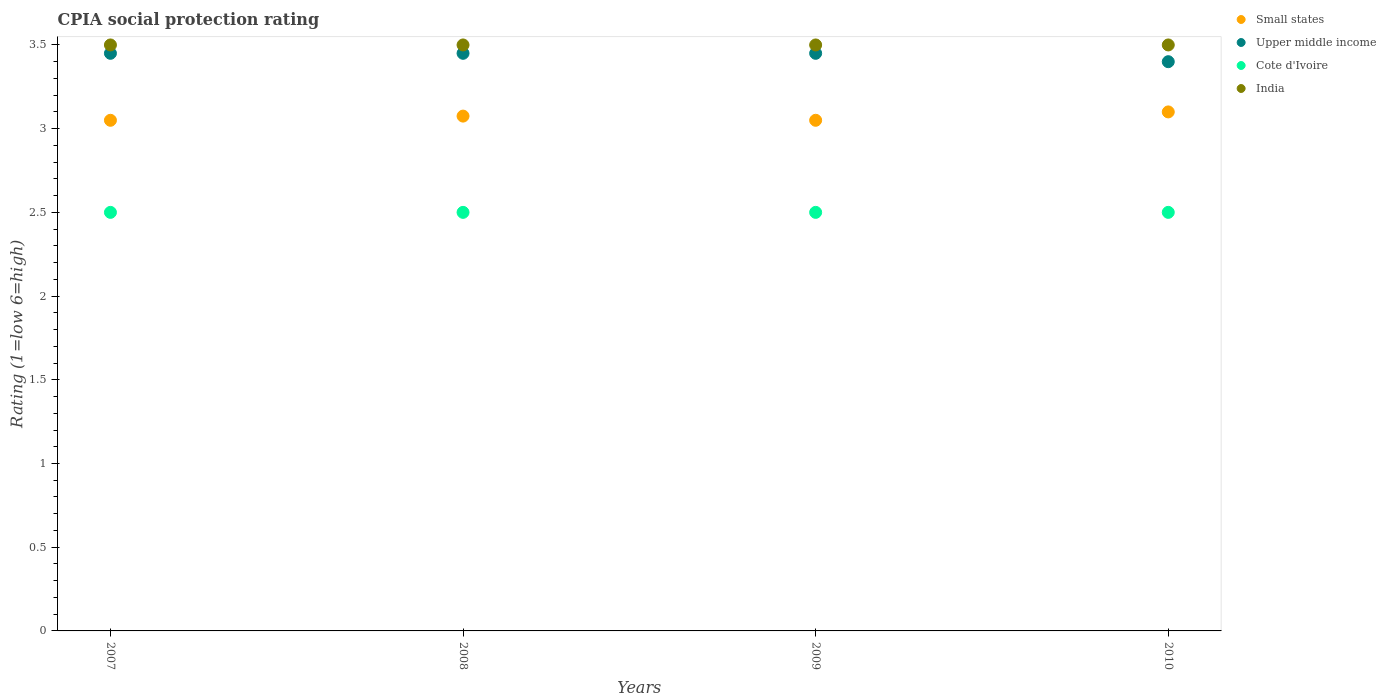How many different coloured dotlines are there?
Keep it short and to the point. 4. Is the number of dotlines equal to the number of legend labels?
Make the answer very short. Yes. What is the CPIA rating in Small states in 2007?
Keep it short and to the point. 3.05. In which year was the CPIA rating in Upper middle income minimum?
Offer a very short reply. 2010. What is the difference between the CPIA rating in Upper middle income in 2007 and that in 2010?
Offer a very short reply. 0.05. What is the difference between the CPIA rating in Small states in 2010 and the CPIA rating in Upper middle income in 2009?
Ensure brevity in your answer.  -0.35. What is the average CPIA rating in Cote d'Ivoire per year?
Provide a short and direct response. 2.5. In the year 2009, what is the difference between the CPIA rating in Upper middle income and CPIA rating in Small states?
Your response must be concise. 0.4. In how many years, is the CPIA rating in Small states greater than 2.2?
Provide a short and direct response. 4. What is the ratio of the CPIA rating in Small states in 2008 to that in 2009?
Ensure brevity in your answer.  1.01. Is the CPIA rating in Cote d'Ivoire in 2007 less than that in 2009?
Give a very brief answer. No. What is the difference between the highest and the second highest CPIA rating in Small states?
Your answer should be very brief. 0.02. Is it the case that in every year, the sum of the CPIA rating in Cote d'Ivoire and CPIA rating in Small states  is greater than the sum of CPIA rating in Upper middle income and CPIA rating in India?
Ensure brevity in your answer.  No. Does the CPIA rating in India monotonically increase over the years?
Offer a terse response. No. Is the CPIA rating in Upper middle income strictly less than the CPIA rating in India over the years?
Offer a terse response. Yes. What is the difference between two consecutive major ticks on the Y-axis?
Your answer should be very brief. 0.5. Does the graph contain any zero values?
Ensure brevity in your answer.  No. Does the graph contain grids?
Offer a very short reply. No. How are the legend labels stacked?
Provide a succinct answer. Vertical. What is the title of the graph?
Your answer should be very brief. CPIA social protection rating. What is the label or title of the Y-axis?
Give a very brief answer. Rating (1=low 6=high). What is the Rating (1=low 6=high) of Small states in 2007?
Your answer should be very brief. 3.05. What is the Rating (1=low 6=high) of Upper middle income in 2007?
Keep it short and to the point. 3.45. What is the Rating (1=low 6=high) in Cote d'Ivoire in 2007?
Offer a very short reply. 2.5. What is the Rating (1=low 6=high) in Small states in 2008?
Make the answer very short. 3.08. What is the Rating (1=low 6=high) in Upper middle income in 2008?
Offer a terse response. 3.45. What is the Rating (1=low 6=high) of Cote d'Ivoire in 2008?
Provide a short and direct response. 2.5. What is the Rating (1=low 6=high) of Small states in 2009?
Offer a terse response. 3.05. What is the Rating (1=low 6=high) of Upper middle income in 2009?
Keep it short and to the point. 3.45. What is the Rating (1=low 6=high) in India in 2009?
Your response must be concise. 3.5. What is the Rating (1=low 6=high) of Small states in 2010?
Keep it short and to the point. 3.1. What is the Rating (1=low 6=high) of India in 2010?
Offer a terse response. 3.5. Across all years, what is the maximum Rating (1=low 6=high) in Upper middle income?
Your answer should be very brief. 3.45. Across all years, what is the maximum Rating (1=low 6=high) of India?
Your answer should be compact. 3.5. Across all years, what is the minimum Rating (1=low 6=high) in Small states?
Your response must be concise. 3.05. Across all years, what is the minimum Rating (1=low 6=high) in Upper middle income?
Make the answer very short. 3.4. Across all years, what is the minimum Rating (1=low 6=high) in Cote d'Ivoire?
Provide a short and direct response. 2.5. What is the total Rating (1=low 6=high) of Small states in the graph?
Your response must be concise. 12.28. What is the total Rating (1=low 6=high) of Upper middle income in the graph?
Your answer should be very brief. 13.75. What is the difference between the Rating (1=low 6=high) of Small states in 2007 and that in 2008?
Your response must be concise. -0.03. What is the difference between the Rating (1=low 6=high) in India in 2007 and that in 2008?
Keep it short and to the point. 0. What is the difference between the Rating (1=low 6=high) of Cote d'Ivoire in 2007 and that in 2010?
Your answer should be very brief. 0. What is the difference between the Rating (1=low 6=high) of Small states in 2008 and that in 2009?
Your answer should be compact. 0.03. What is the difference between the Rating (1=low 6=high) of Upper middle income in 2008 and that in 2009?
Your response must be concise. 0. What is the difference between the Rating (1=low 6=high) of Cote d'Ivoire in 2008 and that in 2009?
Your response must be concise. 0. What is the difference between the Rating (1=low 6=high) in India in 2008 and that in 2009?
Make the answer very short. 0. What is the difference between the Rating (1=low 6=high) of Small states in 2008 and that in 2010?
Your answer should be very brief. -0.03. What is the difference between the Rating (1=low 6=high) in Small states in 2009 and that in 2010?
Provide a succinct answer. -0.05. What is the difference between the Rating (1=low 6=high) of Upper middle income in 2009 and that in 2010?
Provide a short and direct response. 0.05. What is the difference between the Rating (1=low 6=high) in Cote d'Ivoire in 2009 and that in 2010?
Ensure brevity in your answer.  0. What is the difference between the Rating (1=low 6=high) in India in 2009 and that in 2010?
Provide a short and direct response. 0. What is the difference between the Rating (1=low 6=high) of Small states in 2007 and the Rating (1=low 6=high) of Upper middle income in 2008?
Offer a very short reply. -0.4. What is the difference between the Rating (1=low 6=high) in Small states in 2007 and the Rating (1=low 6=high) in Cote d'Ivoire in 2008?
Keep it short and to the point. 0.55. What is the difference between the Rating (1=low 6=high) in Small states in 2007 and the Rating (1=low 6=high) in India in 2008?
Offer a terse response. -0.45. What is the difference between the Rating (1=low 6=high) of Cote d'Ivoire in 2007 and the Rating (1=low 6=high) of India in 2008?
Your answer should be very brief. -1. What is the difference between the Rating (1=low 6=high) in Small states in 2007 and the Rating (1=low 6=high) in Cote d'Ivoire in 2009?
Your response must be concise. 0.55. What is the difference between the Rating (1=low 6=high) in Small states in 2007 and the Rating (1=low 6=high) in India in 2009?
Your response must be concise. -0.45. What is the difference between the Rating (1=low 6=high) in Upper middle income in 2007 and the Rating (1=low 6=high) in Cote d'Ivoire in 2009?
Your answer should be very brief. 0.95. What is the difference between the Rating (1=low 6=high) of Cote d'Ivoire in 2007 and the Rating (1=low 6=high) of India in 2009?
Your answer should be very brief. -1. What is the difference between the Rating (1=low 6=high) of Small states in 2007 and the Rating (1=low 6=high) of Upper middle income in 2010?
Offer a terse response. -0.35. What is the difference between the Rating (1=low 6=high) of Small states in 2007 and the Rating (1=low 6=high) of Cote d'Ivoire in 2010?
Keep it short and to the point. 0.55. What is the difference between the Rating (1=low 6=high) of Small states in 2007 and the Rating (1=low 6=high) of India in 2010?
Keep it short and to the point. -0.45. What is the difference between the Rating (1=low 6=high) of Cote d'Ivoire in 2007 and the Rating (1=low 6=high) of India in 2010?
Your response must be concise. -1. What is the difference between the Rating (1=low 6=high) in Small states in 2008 and the Rating (1=low 6=high) in Upper middle income in 2009?
Keep it short and to the point. -0.38. What is the difference between the Rating (1=low 6=high) in Small states in 2008 and the Rating (1=low 6=high) in Cote d'Ivoire in 2009?
Provide a short and direct response. 0.57. What is the difference between the Rating (1=low 6=high) in Small states in 2008 and the Rating (1=low 6=high) in India in 2009?
Your answer should be compact. -0.42. What is the difference between the Rating (1=low 6=high) of Upper middle income in 2008 and the Rating (1=low 6=high) of India in 2009?
Provide a short and direct response. -0.05. What is the difference between the Rating (1=low 6=high) in Cote d'Ivoire in 2008 and the Rating (1=low 6=high) in India in 2009?
Your answer should be very brief. -1. What is the difference between the Rating (1=low 6=high) in Small states in 2008 and the Rating (1=low 6=high) in Upper middle income in 2010?
Your answer should be very brief. -0.33. What is the difference between the Rating (1=low 6=high) in Small states in 2008 and the Rating (1=low 6=high) in Cote d'Ivoire in 2010?
Your answer should be very brief. 0.57. What is the difference between the Rating (1=low 6=high) in Small states in 2008 and the Rating (1=low 6=high) in India in 2010?
Keep it short and to the point. -0.42. What is the difference between the Rating (1=low 6=high) of Small states in 2009 and the Rating (1=low 6=high) of Upper middle income in 2010?
Your response must be concise. -0.35. What is the difference between the Rating (1=low 6=high) in Small states in 2009 and the Rating (1=low 6=high) in Cote d'Ivoire in 2010?
Make the answer very short. 0.55. What is the difference between the Rating (1=low 6=high) in Small states in 2009 and the Rating (1=low 6=high) in India in 2010?
Keep it short and to the point. -0.45. What is the average Rating (1=low 6=high) in Small states per year?
Provide a short and direct response. 3.07. What is the average Rating (1=low 6=high) of Upper middle income per year?
Offer a terse response. 3.44. In the year 2007, what is the difference between the Rating (1=low 6=high) of Small states and Rating (1=low 6=high) of Cote d'Ivoire?
Give a very brief answer. 0.55. In the year 2007, what is the difference between the Rating (1=low 6=high) of Small states and Rating (1=low 6=high) of India?
Give a very brief answer. -0.45. In the year 2007, what is the difference between the Rating (1=low 6=high) in Upper middle income and Rating (1=low 6=high) in India?
Provide a short and direct response. -0.05. In the year 2008, what is the difference between the Rating (1=low 6=high) of Small states and Rating (1=low 6=high) of Upper middle income?
Keep it short and to the point. -0.38. In the year 2008, what is the difference between the Rating (1=low 6=high) in Small states and Rating (1=low 6=high) in Cote d'Ivoire?
Your answer should be compact. 0.57. In the year 2008, what is the difference between the Rating (1=low 6=high) in Small states and Rating (1=low 6=high) in India?
Ensure brevity in your answer.  -0.42. In the year 2009, what is the difference between the Rating (1=low 6=high) of Small states and Rating (1=low 6=high) of Cote d'Ivoire?
Offer a terse response. 0.55. In the year 2009, what is the difference between the Rating (1=low 6=high) of Small states and Rating (1=low 6=high) of India?
Provide a short and direct response. -0.45. In the year 2009, what is the difference between the Rating (1=low 6=high) of Upper middle income and Rating (1=low 6=high) of Cote d'Ivoire?
Offer a terse response. 0.95. In the year 2009, what is the difference between the Rating (1=low 6=high) in Cote d'Ivoire and Rating (1=low 6=high) in India?
Keep it short and to the point. -1. In the year 2010, what is the difference between the Rating (1=low 6=high) of Small states and Rating (1=low 6=high) of Cote d'Ivoire?
Give a very brief answer. 0.6. In the year 2010, what is the difference between the Rating (1=low 6=high) of Upper middle income and Rating (1=low 6=high) of India?
Make the answer very short. -0.1. What is the ratio of the Rating (1=low 6=high) of Cote d'Ivoire in 2007 to that in 2008?
Provide a succinct answer. 1. What is the ratio of the Rating (1=low 6=high) of India in 2007 to that in 2008?
Your answer should be compact. 1. What is the ratio of the Rating (1=low 6=high) of Small states in 2007 to that in 2009?
Make the answer very short. 1. What is the ratio of the Rating (1=low 6=high) of Cote d'Ivoire in 2007 to that in 2009?
Provide a succinct answer. 1. What is the ratio of the Rating (1=low 6=high) in India in 2007 to that in 2009?
Make the answer very short. 1. What is the ratio of the Rating (1=low 6=high) of Small states in 2007 to that in 2010?
Offer a terse response. 0.98. What is the ratio of the Rating (1=low 6=high) in Upper middle income in 2007 to that in 2010?
Offer a very short reply. 1.01. What is the ratio of the Rating (1=low 6=high) of Cote d'Ivoire in 2007 to that in 2010?
Provide a short and direct response. 1. What is the ratio of the Rating (1=low 6=high) of India in 2007 to that in 2010?
Make the answer very short. 1. What is the ratio of the Rating (1=low 6=high) in Small states in 2008 to that in 2009?
Make the answer very short. 1.01. What is the ratio of the Rating (1=low 6=high) in Upper middle income in 2008 to that in 2009?
Keep it short and to the point. 1. What is the ratio of the Rating (1=low 6=high) of India in 2008 to that in 2009?
Your answer should be very brief. 1. What is the ratio of the Rating (1=low 6=high) in Upper middle income in 2008 to that in 2010?
Offer a terse response. 1.01. What is the ratio of the Rating (1=low 6=high) in India in 2008 to that in 2010?
Offer a very short reply. 1. What is the ratio of the Rating (1=low 6=high) of Small states in 2009 to that in 2010?
Give a very brief answer. 0.98. What is the ratio of the Rating (1=low 6=high) in Upper middle income in 2009 to that in 2010?
Make the answer very short. 1.01. What is the ratio of the Rating (1=low 6=high) of India in 2009 to that in 2010?
Your answer should be compact. 1. What is the difference between the highest and the second highest Rating (1=low 6=high) in Small states?
Your answer should be compact. 0.03. What is the difference between the highest and the second highest Rating (1=low 6=high) of Upper middle income?
Provide a short and direct response. 0. What is the difference between the highest and the second highest Rating (1=low 6=high) in Cote d'Ivoire?
Ensure brevity in your answer.  0. What is the difference between the highest and the lowest Rating (1=low 6=high) of Small states?
Offer a very short reply. 0.05. What is the difference between the highest and the lowest Rating (1=low 6=high) of Upper middle income?
Provide a short and direct response. 0.05. 